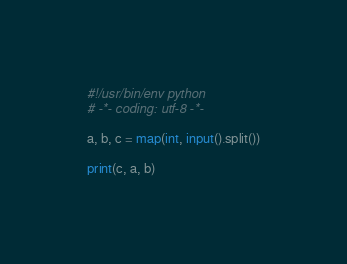<code> <loc_0><loc_0><loc_500><loc_500><_Python_>#!/usr/bin/env python
# -*- coding: utf-8 -*-

a, b, c = map(int, input().split())

print(c, a, b)
</code> 